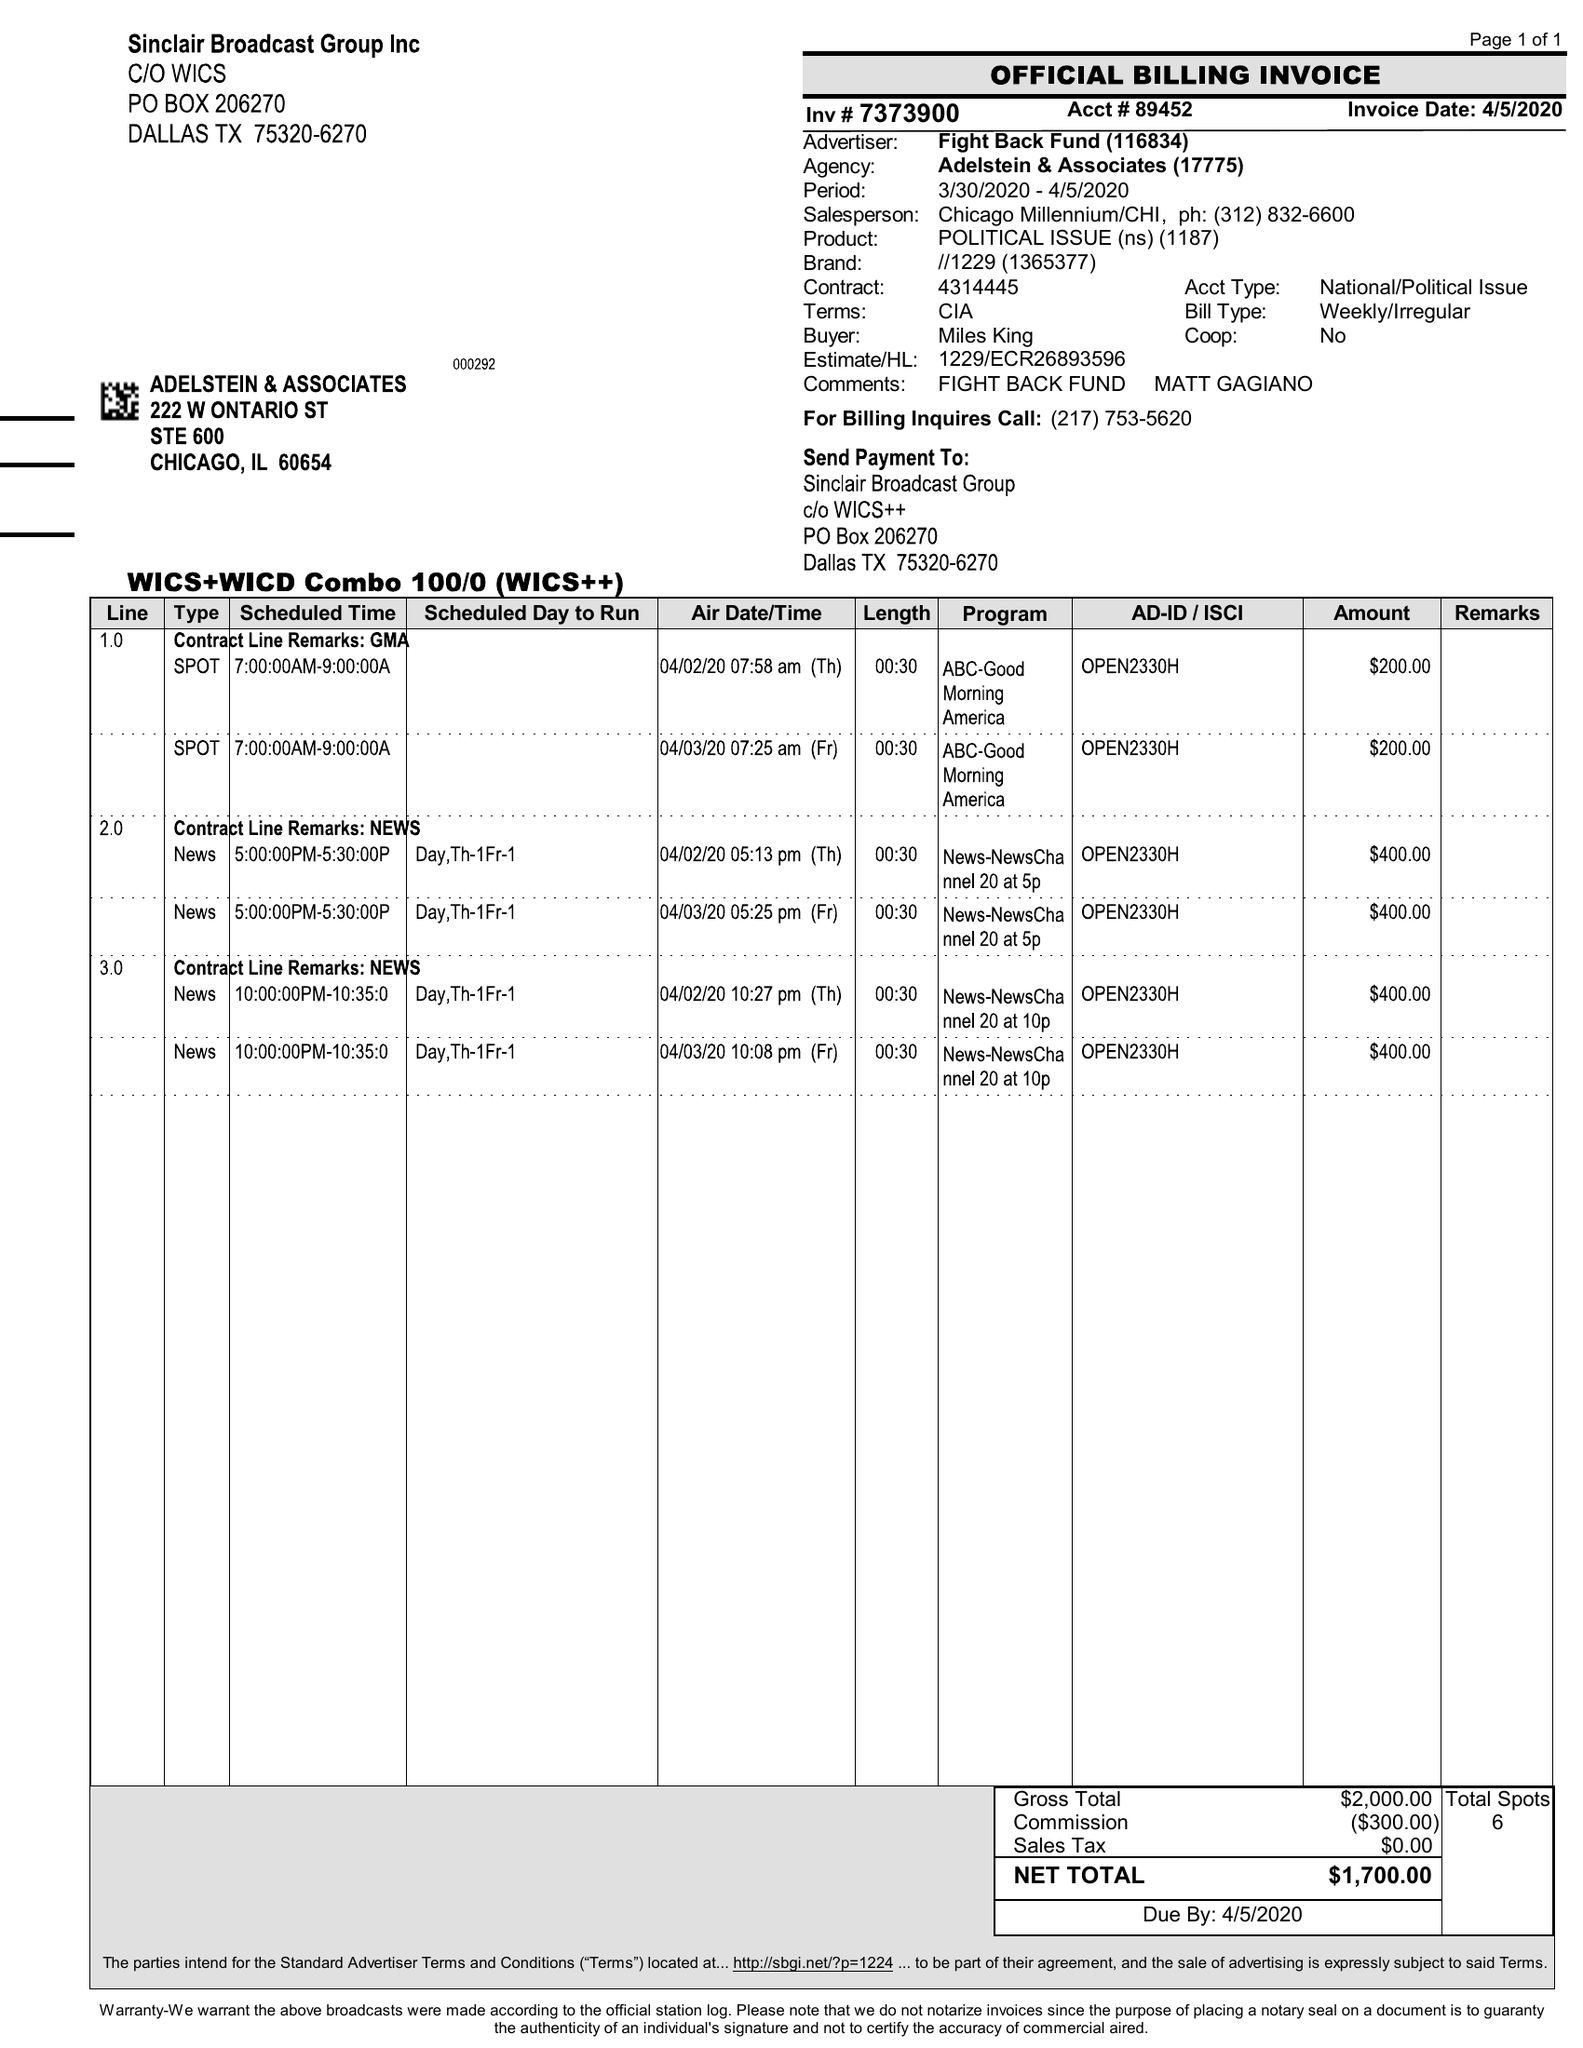What is the value for the flight_to?
Answer the question using a single word or phrase. 04/05/20 